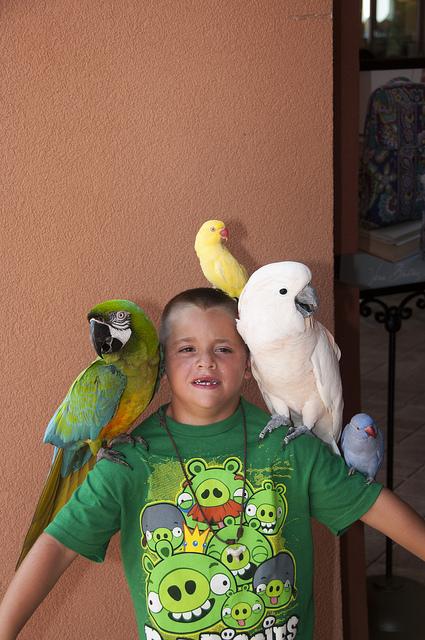What type of bird is on his right shoulder?
Give a very brief answer. Parrot. Is there a cartoon mustache in the picture?
Write a very short answer. Yes. What is on the boy?
Quick response, please. Birds. 